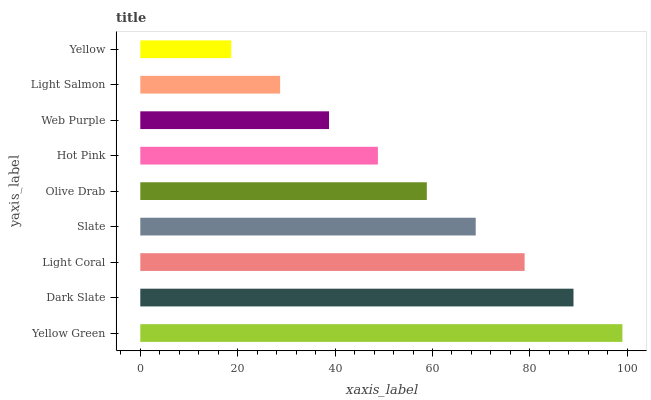Is Yellow the minimum?
Answer yes or no. Yes. Is Yellow Green the maximum?
Answer yes or no. Yes. Is Dark Slate the minimum?
Answer yes or no. No. Is Dark Slate the maximum?
Answer yes or no. No. Is Yellow Green greater than Dark Slate?
Answer yes or no. Yes. Is Dark Slate less than Yellow Green?
Answer yes or no. Yes. Is Dark Slate greater than Yellow Green?
Answer yes or no. No. Is Yellow Green less than Dark Slate?
Answer yes or no. No. Is Olive Drab the high median?
Answer yes or no. Yes. Is Olive Drab the low median?
Answer yes or no. Yes. Is Hot Pink the high median?
Answer yes or no. No. Is Yellow Green the low median?
Answer yes or no. No. 